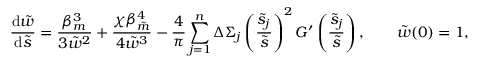Convert formula to latex. <formula><loc_0><loc_0><loc_500><loc_500>\frac { d \tilde { w } } { d \tilde { s } } = \frac { \beta _ { m } ^ { 3 } } { 3 \tilde { w } ^ { 2 } } + \frac { \chi \beta _ { \tilde { m } } ^ { 4 } } { 4 \tilde { w } ^ { 3 } } - \frac { 4 } { \pi } \sum _ { j = 1 } ^ { n } \Delta \Sigma _ { j } \left ( \frac { \tilde { s } _ { j } } { \tilde { s } } \right ) ^ { 2 } G ^ { \prime } \left ( \frac { \tilde { s } _ { j } } { \tilde { s } } \right ) , \quad \tilde { w } ( 0 ) = 1 ,</formula> 